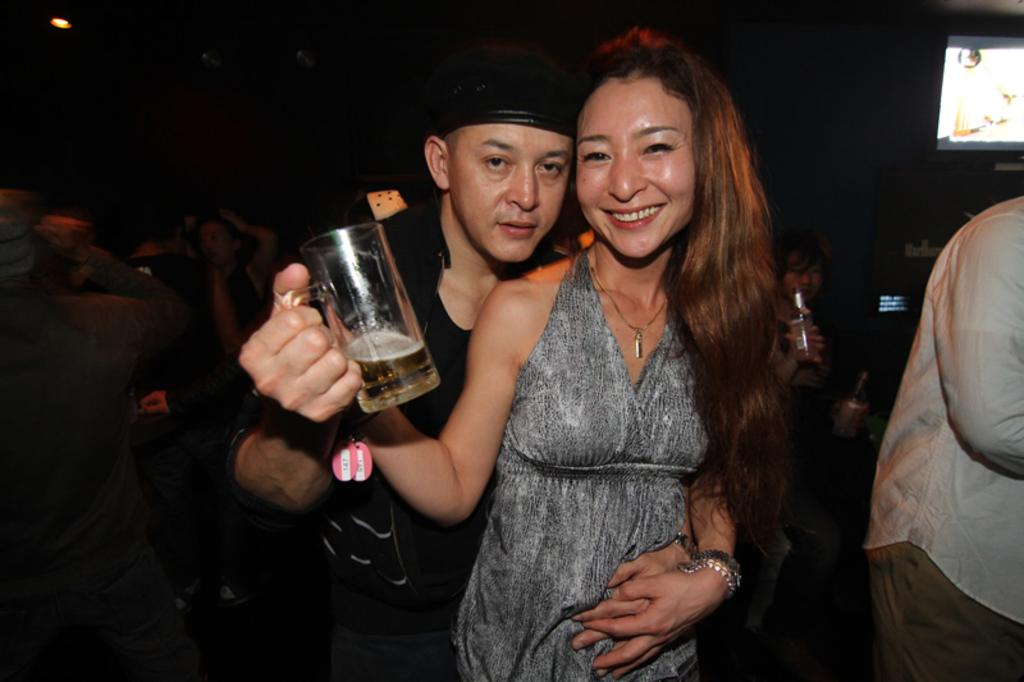How many people are present in the image? There is a woman and a man in the image, as well as additional people. What are the man and woman doing in the image? The man and woman are holding each other. What is the man holding in his hand? The man is holding a glass. What type of cabbage is being used as a road in the image? There is no cabbage or road present in the image. 